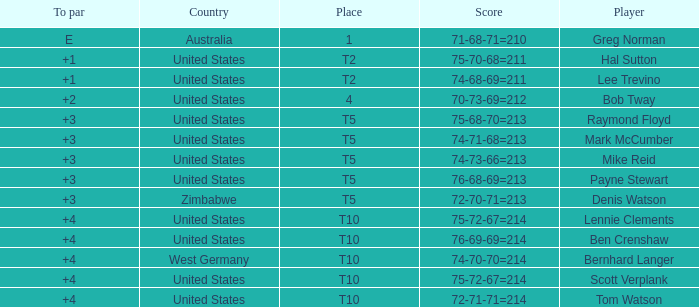Which nation does raymond floyd, the player, represent? United States. 